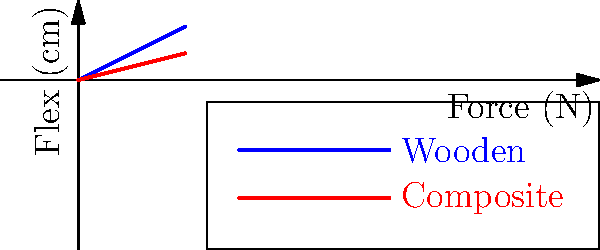The graph shows the relationship between applied force and flex for wooden and composite hockey sticks. Based on this information, which type of stick would provide more "feel" or feedback to the player during a shot, and why? To answer this question, we need to analyze the graph and understand the concept of stick flex:

1. The x-axis represents the applied force (N), and the y-axis represents the flex (cm).
2. The blue line represents the wooden stick, while the red line represents the composite stick.
3. The slope of each line indicates how much the stick flexes for a given force:
   - Wooden stick: steeper slope
   - Composite stick: less steep slope

4. A steeper slope means more flex for the same amount of force:
   - For wooden sticks: $\text{Flex} = 0.5 \times \text{Force}$
   - For composite sticks: $\text{Flex} = 0.25 \times \text{Force}$

5. More flex translates to more "feel" or feedback to the player:
   - The wooden stick bends more for the same force, providing more tactile sensation.
   - This increased flex allows players to better sense the puck on their stick.

6. The traditional feel of wooden sticks comes from this higher flex characteristic:
   - Players can "load" the stick more during a shot, feeling the energy transfer.
   - This can lead to a better sense of shot power and accuracy for experienced players.

Therefore, based on the graph, the wooden stick would provide more "feel" or feedback to the player during a shot due to its higher flex characteristics.
Answer: Wooden stick, due to higher flex. 